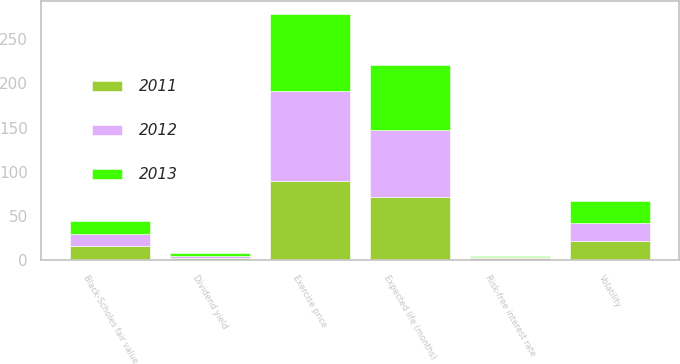Convert chart. <chart><loc_0><loc_0><loc_500><loc_500><stacked_bar_chart><ecel><fcel>Exercise price<fcel>Risk-free interest rate<fcel>Dividend yield<fcel>Volatility<fcel>Expected life (months)<fcel>Black-Scholes fair value<nl><fcel>2012<fcel>101.49<fcel>1.2<fcel>2.7<fcel>20<fcel>75<fcel>13.46<nl><fcel>2013<fcel>87.89<fcel>1.1<fcel>2.6<fcel>24.5<fcel>74<fcel>14.94<nl><fcel>2011<fcel>89.47<fcel>2.8<fcel>2.6<fcel>22<fcel>72<fcel>16.1<nl></chart> 